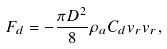Convert formula to latex. <formula><loc_0><loc_0><loc_500><loc_500>F _ { d } = - \frac { \pi D ^ { 2 } } { 8 } \rho _ { a } C _ { d } v _ { r } v _ { r } ,</formula> 